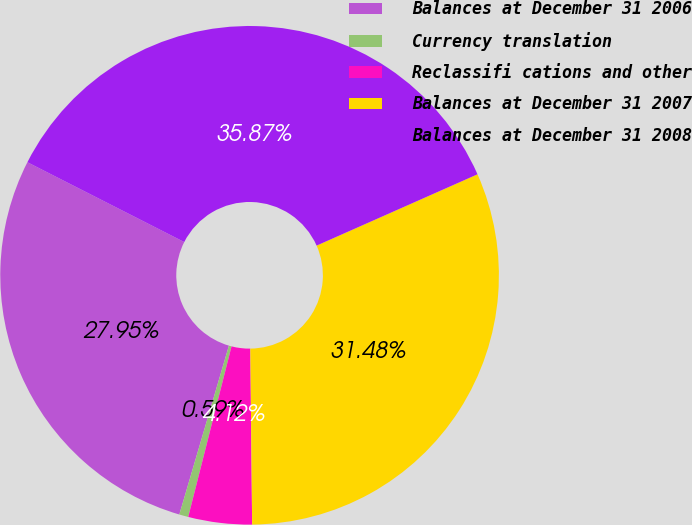Convert chart. <chart><loc_0><loc_0><loc_500><loc_500><pie_chart><fcel>Balances at December 31 2006<fcel>Currency translation<fcel>Reclassifi cations and other<fcel>Balances at December 31 2007<fcel>Balances at December 31 2008<nl><fcel>27.95%<fcel>0.59%<fcel>4.12%<fcel>31.48%<fcel>35.87%<nl></chart> 